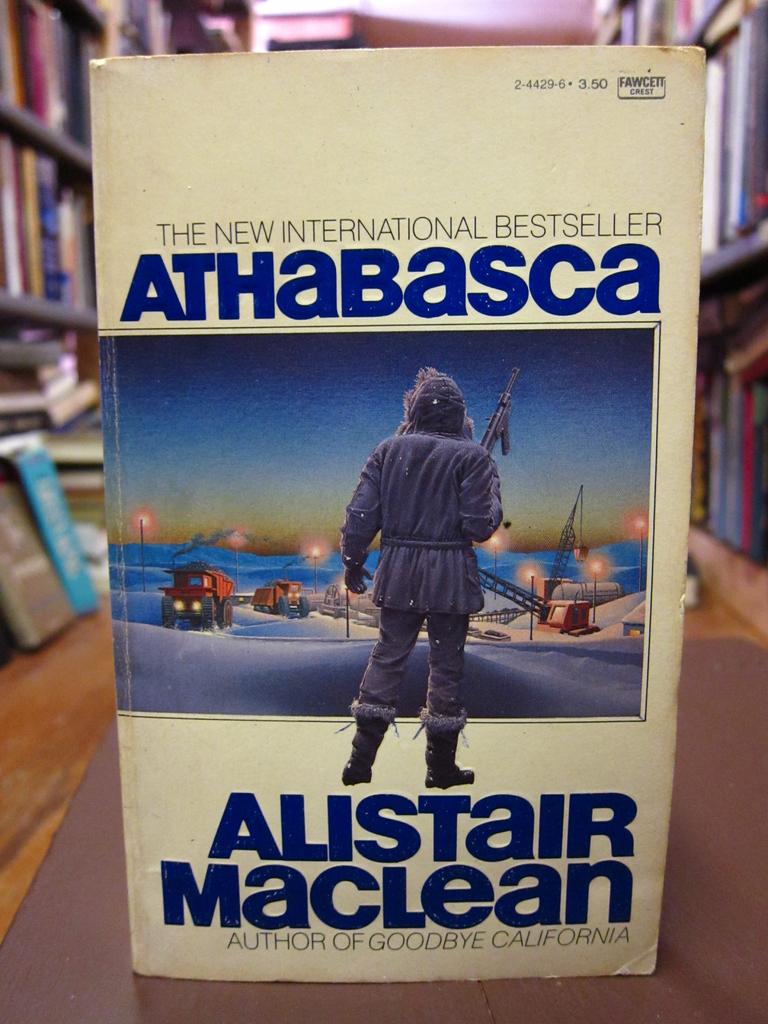What is the title of the book?
Your answer should be compact. Athabasca. 